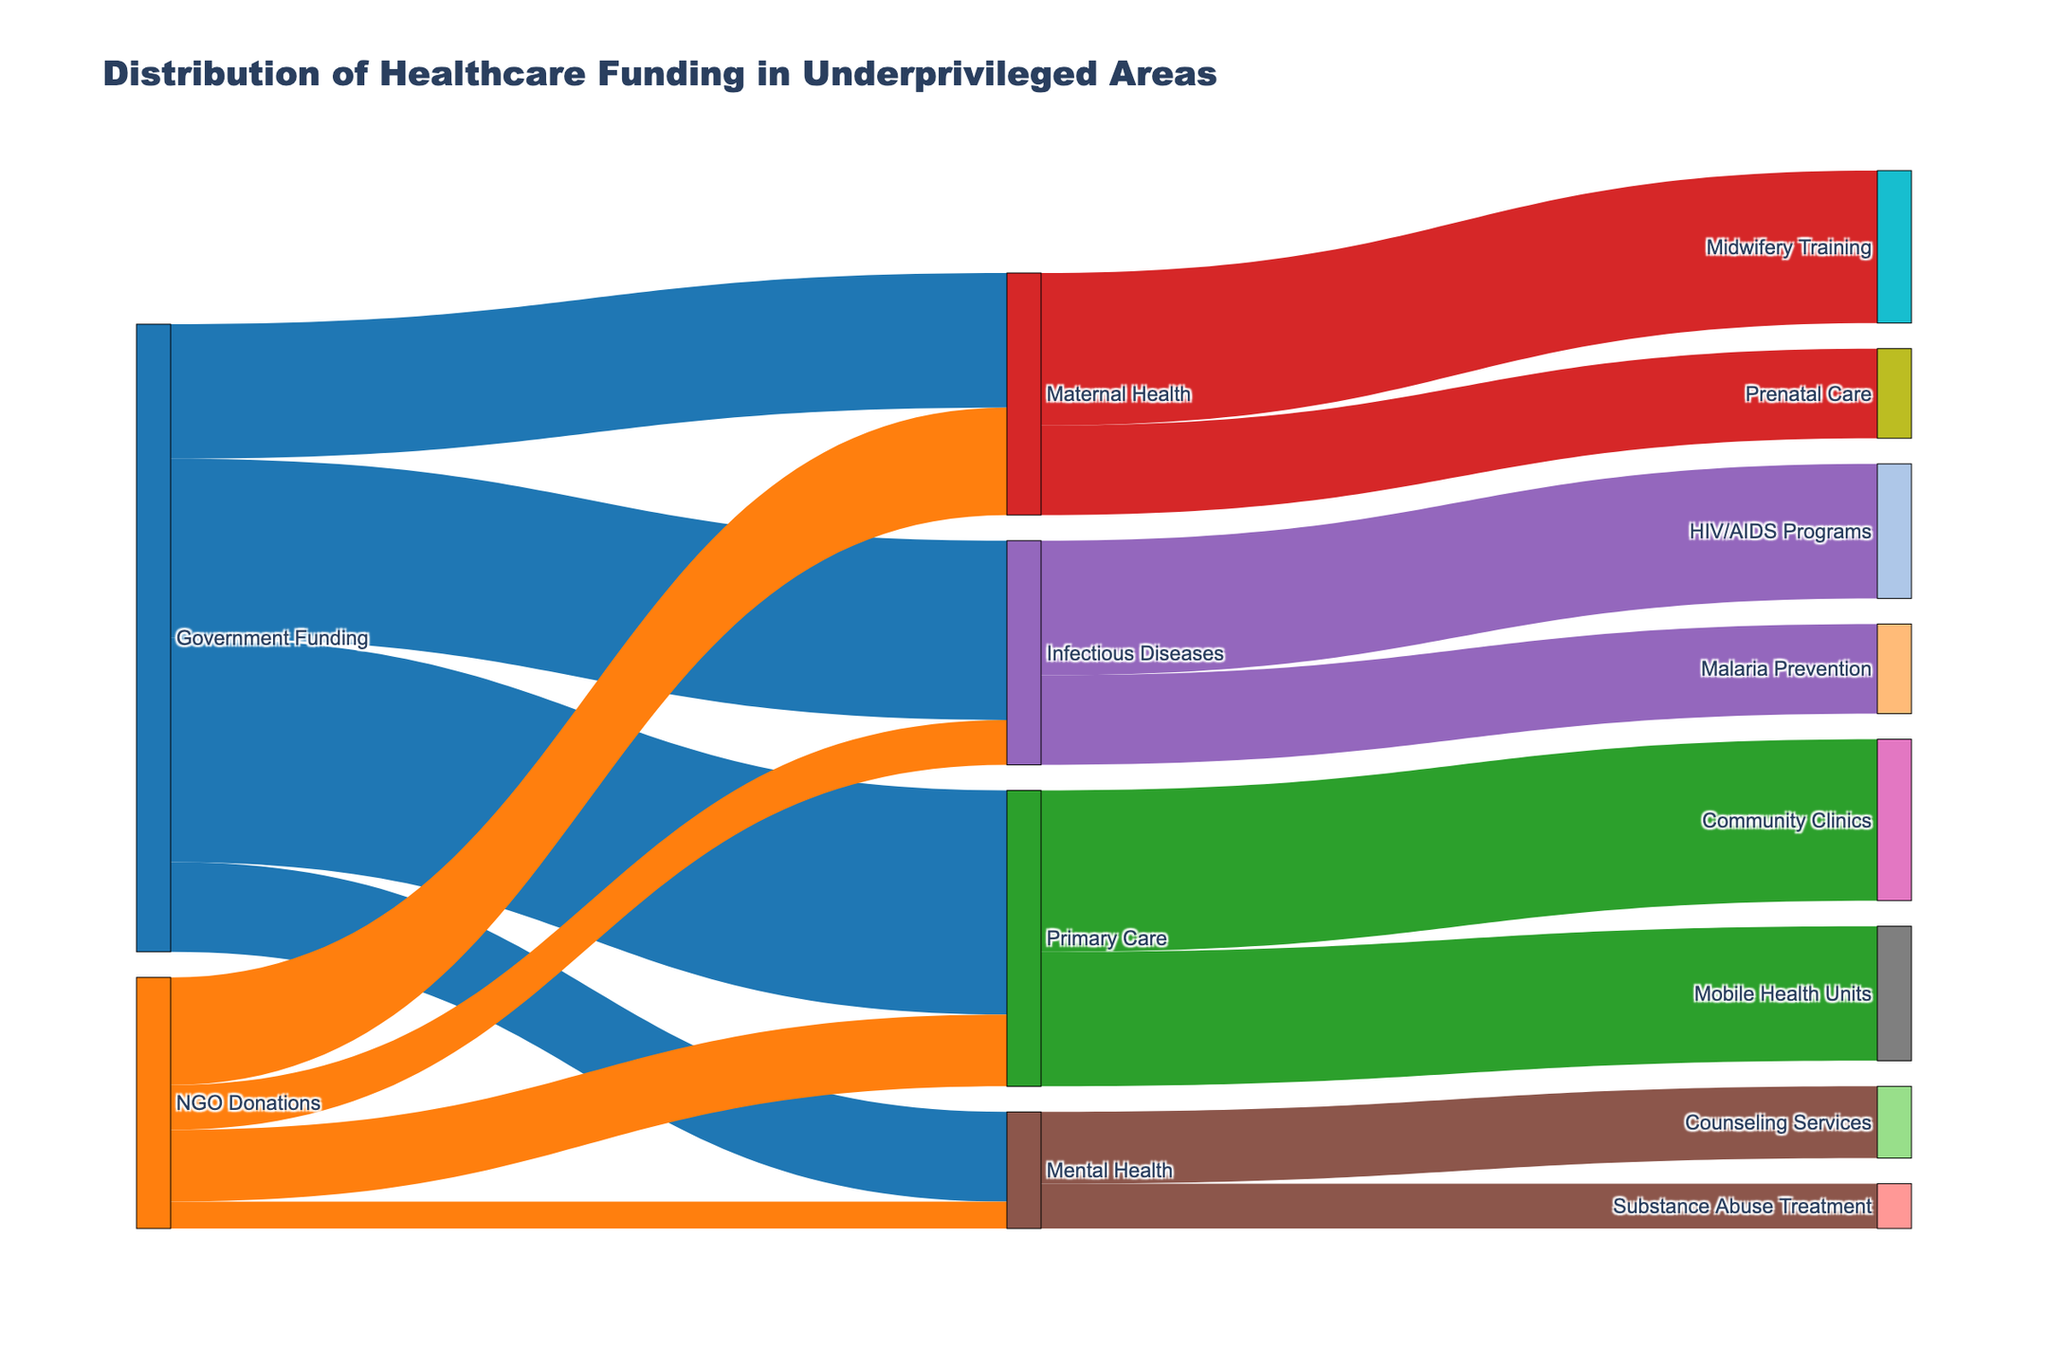What's the total amount of funding received by Mental Health programs? Add the values of funding directed towards Mental Health from both Government Funding and NGO Donations, which are $10,000,000 and $3,000,000 respectively. $10,000,000 + $3,000,000 = $13,000,000
Answer: $13,000,000 What is the primary care funding amount from the government compared to NGO donations? The Government Funding for Primary Care is $25,000,000 and the NGO Donations for Primary Care is $8,000,000. 25,000,000 > 8,000,000
Answer: Government Funding is more by $17,000,000 How much total funding goes to Maternal Health projects? Sum the values directed to Maternal Health from both Government Funding and NGO Donations, which are $15,000,000 and $12,000,000 respectively. $15,000,000 + $12,000,000 = $27,000,000
Answer: $27,000,000 Between Primary Care and Infectious Diseases, which receives more funding from NGO Donations? By looking at the NGO Donations, Infectious Diseases receive $5,000,000 while Primary Care receives $8,000,000. 8,000,000 > 5,000,000
Answer: Primary Care What is the combined funding amount for Malaria Prevention programs? Malaria Prevention programs receive $10,000,000 directed only from Infectious Diseases. No additional breakdown required.
Answer: $10,000,000 Which secondary initiative under Primary Care receives the highest funding? Under Primary Care, Community Clinics receive $18,000,000 and Mobile Health Units receive $15,000,000. 18,000,000 > 15,000,000
Answer: Community Clinics Of the given sources, which one contributes the highest total funding towards healthcare in underprivileged areas? Sum the funding from Government and NGO sources. Government: $25,000,000 + $15,000,000 + $20,000,000 + $10,000,000 = $70,000,000, NGO: $8,000,000 + $12,000,000 + $5,000,000 + $3,000,000 = $28,000,000. 70,000,000 > 28,000,000
Answer: Government What is the total funding dedicated to Primary Care projects? Sum all funding for Primary Care: Government ($25,000,000) and NGO ($8,000,000). Then sum the allocated projects: Community Clinics ($18,000,000) and Mobile Health Units ($15,000,000). $25,000,000 + $8,000,000 = $33,000,000, $33,000,000 > $18,000,000 + $15,000,000.
Answer: $33,000,000 